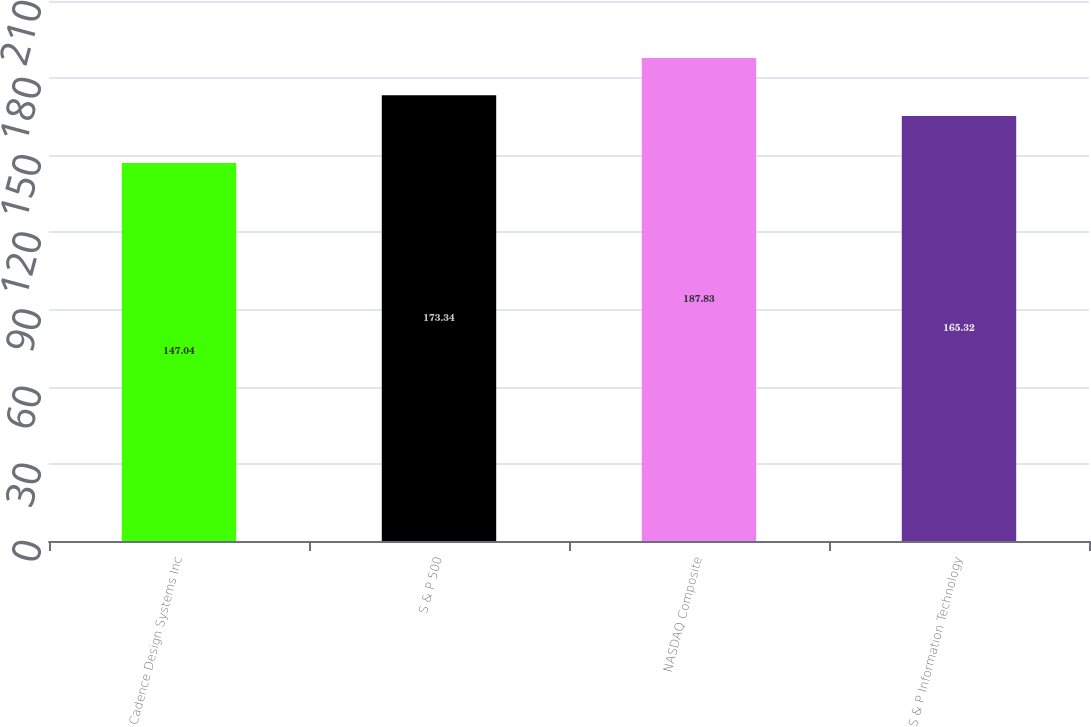<chart> <loc_0><loc_0><loc_500><loc_500><bar_chart><fcel>Cadence Design Systems Inc<fcel>S & P 500<fcel>NASDAQ Composite<fcel>S & P Information Technology<nl><fcel>147.04<fcel>173.34<fcel>187.83<fcel>165.32<nl></chart> 